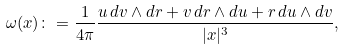<formula> <loc_0><loc_0><loc_500><loc_500>\omega ( x ) \colon = \frac { 1 } { 4 \pi } \frac { u \, d v \wedge d r + v \, d r \wedge d u + r \, d u \wedge d v } { | x | ^ { 3 } } ,</formula> 